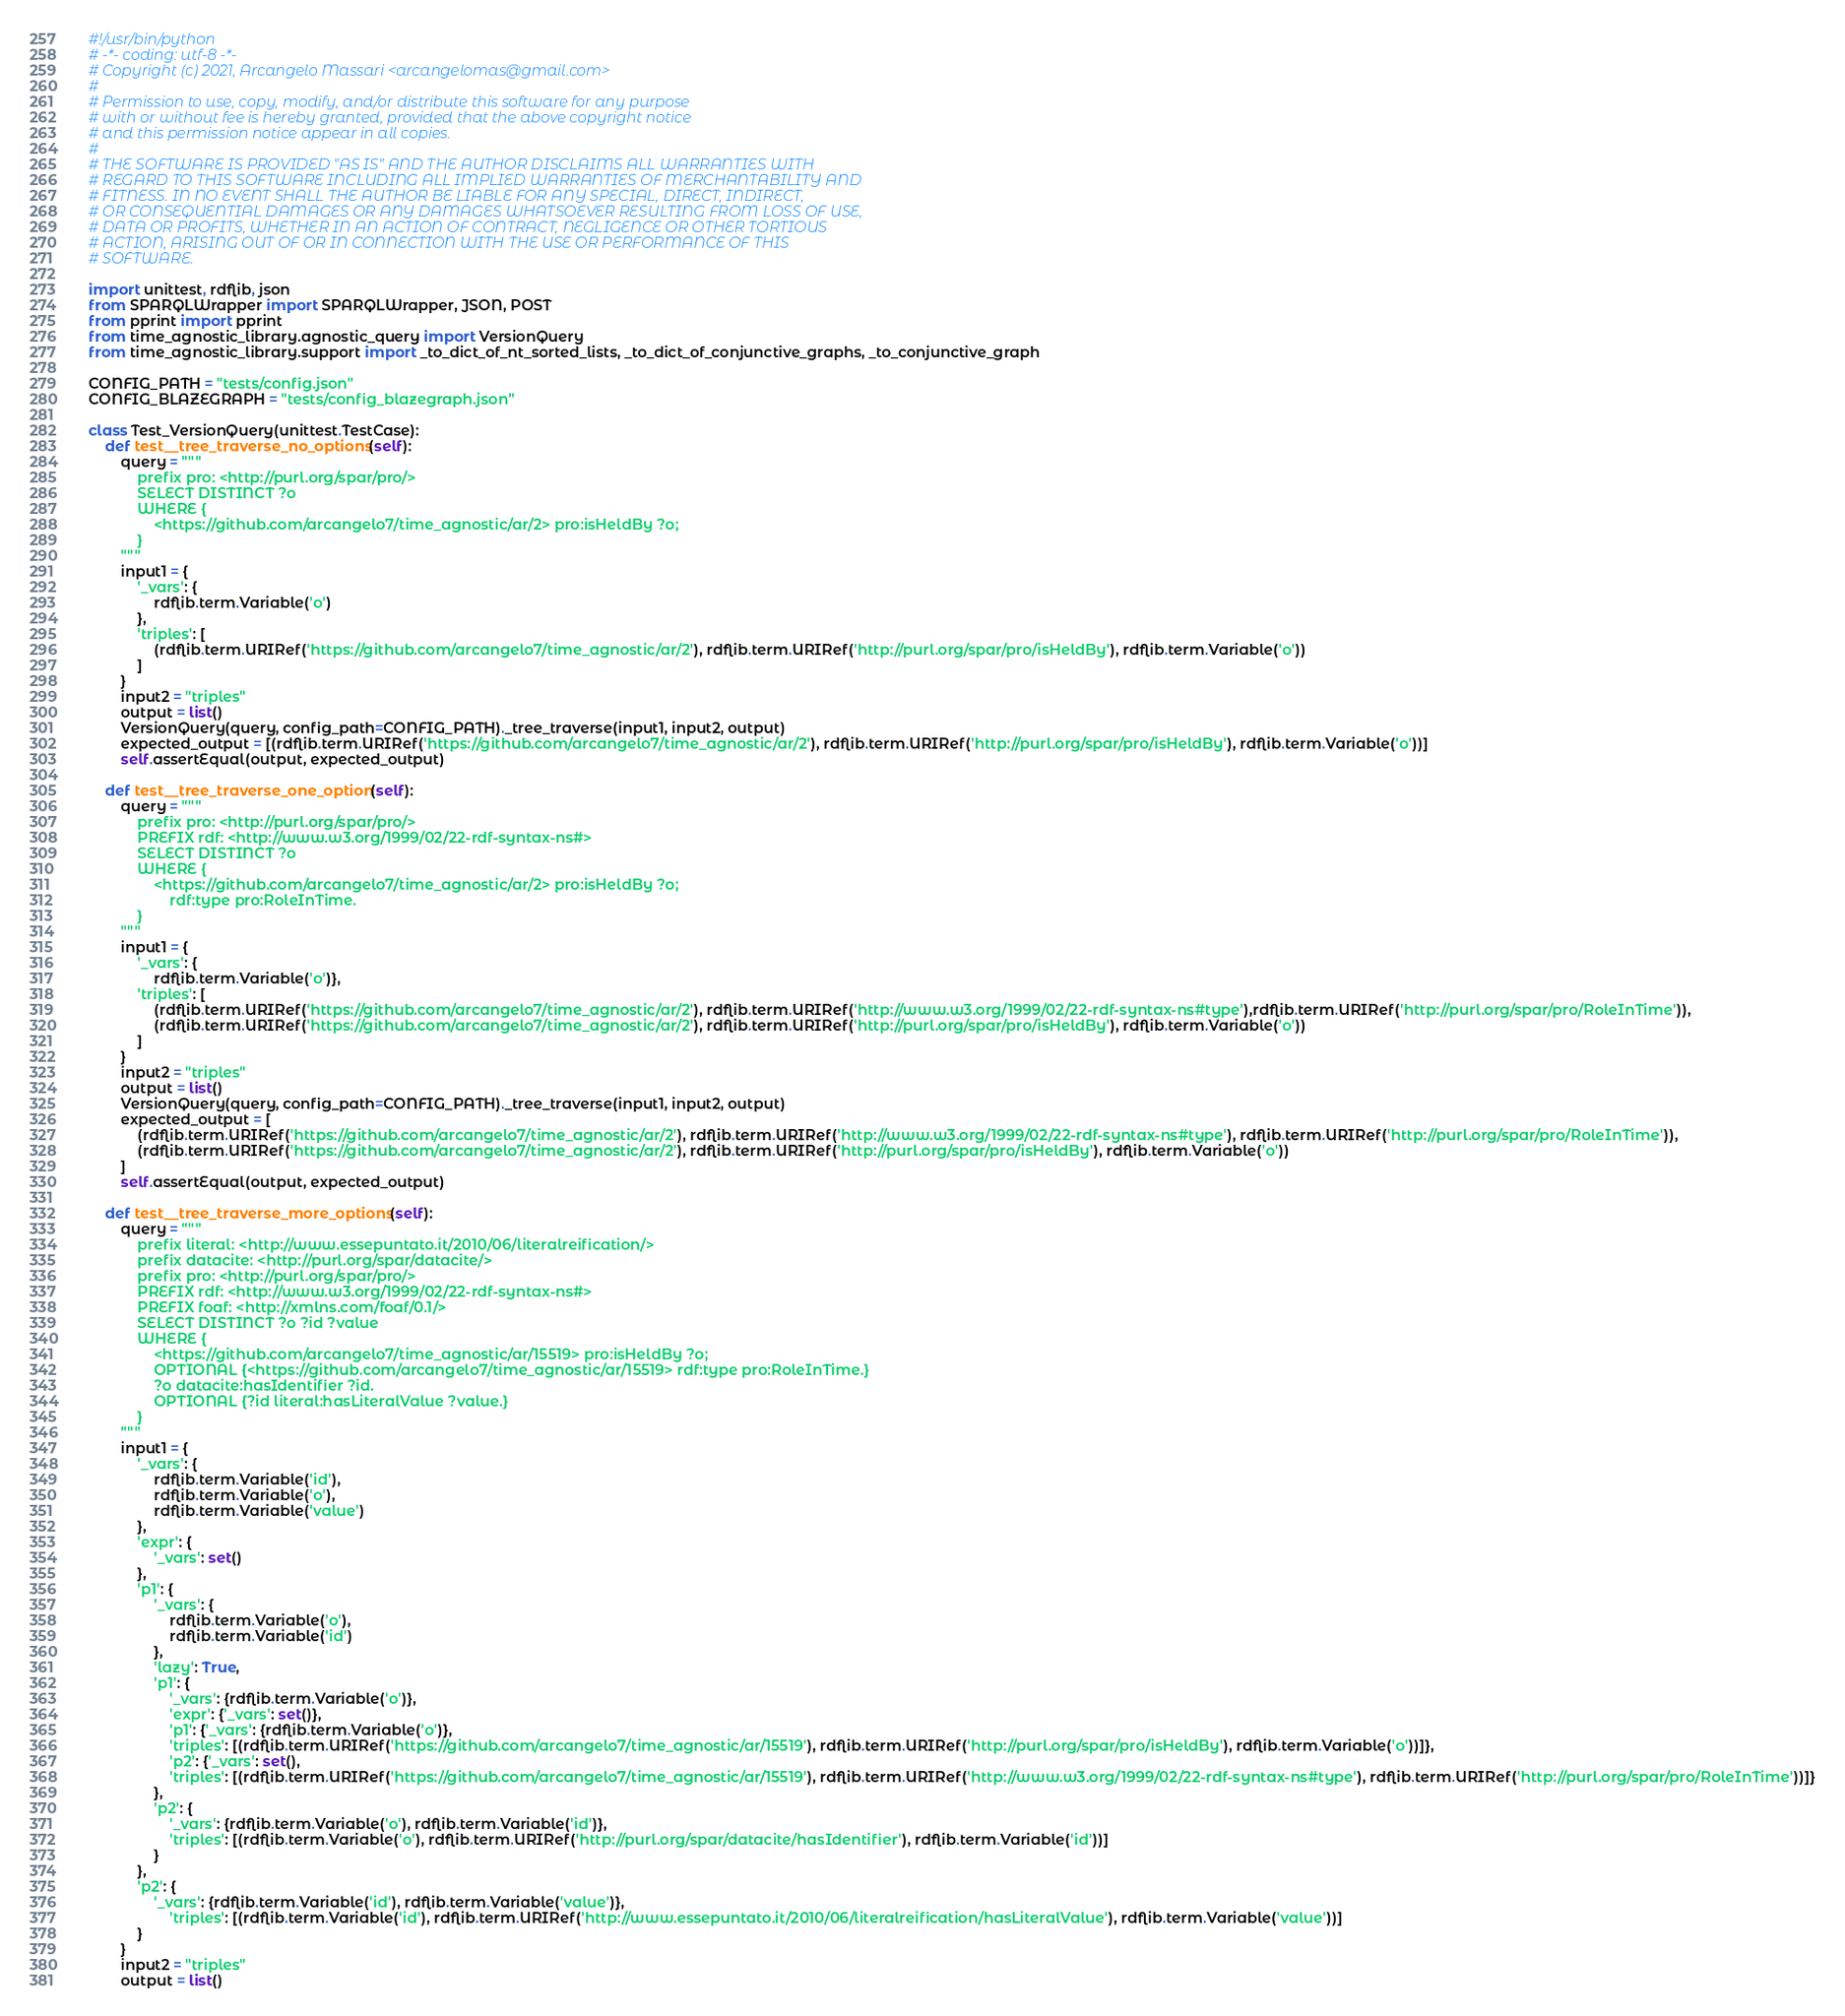Convert code to text. <code><loc_0><loc_0><loc_500><loc_500><_Python_>#!/usr/bin/python
# -*- coding: utf-8 -*-
# Copyright (c) 2021, Arcangelo Massari <arcangelomas@gmail.com>
#
# Permission to use, copy, modify, and/or distribute this software for any purpose
# with or without fee is hereby granted, provided that the above copyright notice
# and this permission notice appear in all copies.
#
# THE SOFTWARE IS PROVIDED "AS IS" AND THE AUTHOR DISCLAIMS ALL WARRANTIES WITH
# REGARD TO THIS SOFTWARE INCLUDING ALL IMPLIED WARRANTIES OF MERCHANTABILITY AND
# FITNESS. IN NO EVENT SHALL THE AUTHOR BE LIABLE FOR ANY SPECIAL, DIRECT, INDIRECT,
# OR CONSEQUENTIAL DAMAGES OR ANY DAMAGES WHATSOEVER RESULTING FROM LOSS OF USE,
# DATA OR PROFITS, WHETHER IN AN ACTION OF CONTRACT, NEGLIGENCE OR OTHER TORTIOUS
# ACTION, ARISING OUT OF OR IN CONNECTION WITH THE USE OR PERFORMANCE OF THIS
# SOFTWARE.

import unittest, rdflib, json
from SPARQLWrapper import SPARQLWrapper, JSON, POST
from pprint import pprint
from time_agnostic_library.agnostic_query import VersionQuery
from time_agnostic_library.support import _to_dict_of_nt_sorted_lists, _to_dict_of_conjunctive_graphs, _to_conjunctive_graph

CONFIG_PATH = "tests/config.json"
CONFIG_BLAZEGRAPH = "tests/config_blazegraph.json"

class Test_VersionQuery(unittest.TestCase):        
    def test__tree_traverse_no_options(self):
        query = """
            prefix pro: <http://purl.org/spar/pro/>
            SELECT DISTINCT ?o
            WHERE {
                <https://github.com/arcangelo7/time_agnostic/ar/2> pro:isHeldBy ?o;
            }
        """
        input1 = {
            '_vars': {
                rdflib.term.Variable('o')
            },
            'triples': [
                (rdflib.term.URIRef('https://github.com/arcangelo7/time_agnostic/ar/2'), rdflib.term.URIRef('http://purl.org/spar/pro/isHeldBy'), rdflib.term.Variable('o'))
            ]
        }
        input2 = "triples"
        output = list()
        VersionQuery(query, config_path=CONFIG_PATH)._tree_traverse(input1, input2, output)
        expected_output = [(rdflib.term.URIRef('https://github.com/arcangelo7/time_agnostic/ar/2'), rdflib.term.URIRef('http://purl.org/spar/pro/isHeldBy'), rdflib.term.Variable('o'))]
        self.assertEqual(output, expected_output)

    def test__tree_traverse_one_option(self):
        query = """
            prefix pro: <http://purl.org/spar/pro/>
            PREFIX rdf: <http://www.w3.org/1999/02/22-rdf-syntax-ns#>
            SELECT DISTINCT ?o
            WHERE {
                <https://github.com/arcangelo7/time_agnostic/ar/2> pro:isHeldBy ?o;
                    rdf:type pro:RoleInTime.
            }
        """
        input1 = {
            '_vars': {
                rdflib.term.Variable('o')},
            'triples': [
                (rdflib.term.URIRef('https://github.com/arcangelo7/time_agnostic/ar/2'), rdflib.term.URIRef('http://www.w3.org/1999/02/22-rdf-syntax-ns#type'),rdflib.term.URIRef('http://purl.org/spar/pro/RoleInTime')),
                (rdflib.term.URIRef('https://github.com/arcangelo7/time_agnostic/ar/2'), rdflib.term.URIRef('http://purl.org/spar/pro/isHeldBy'), rdflib.term.Variable('o'))
            ]
        }
        input2 = "triples"
        output = list()
        VersionQuery(query, config_path=CONFIG_PATH)._tree_traverse(input1, input2, output)
        expected_output = [
            (rdflib.term.URIRef('https://github.com/arcangelo7/time_agnostic/ar/2'), rdflib.term.URIRef('http://www.w3.org/1999/02/22-rdf-syntax-ns#type'), rdflib.term.URIRef('http://purl.org/spar/pro/RoleInTime')), 
            (rdflib.term.URIRef('https://github.com/arcangelo7/time_agnostic/ar/2'), rdflib.term.URIRef('http://purl.org/spar/pro/isHeldBy'), rdflib.term.Variable('o'))
        ]
        self.assertEqual(output, expected_output)

    def test__tree_traverse_more_options(self):
        query = """
            prefix literal: <http://www.essepuntato.it/2010/06/literalreification/>
            prefix datacite: <http://purl.org/spar/datacite/>
            prefix pro: <http://purl.org/spar/pro/>
            PREFIX rdf: <http://www.w3.org/1999/02/22-rdf-syntax-ns#>
            PREFIX foaf: <http://xmlns.com/foaf/0.1/>
            SELECT DISTINCT ?o ?id ?value
            WHERE {
                <https://github.com/arcangelo7/time_agnostic/ar/15519> pro:isHeldBy ?o;
                OPTIONAL {<https://github.com/arcangelo7/time_agnostic/ar/15519> rdf:type pro:RoleInTime.}
                ?o datacite:hasIdentifier ?id.
                OPTIONAL {?id literal:hasLiteralValue ?value.}
            }
        """
        input1 = {
            '_vars': {
                rdflib.term.Variable('id'),
                rdflib.term.Variable('o'),
                rdflib.term.Variable('value')
            },
            'expr': {
                '_vars': set()
            },
            'p1': {
                '_vars': {
                    rdflib.term.Variable('o'), 
                    rdflib.term.Variable('id')
                },
                'lazy': True,
                'p1': {
                    '_vars': {rdflib.term.Variable('o')},
                    'expr': {'_vars': set()},
                    'p1': {'_vars': {rdflib.term.Variable('o')},
                    'triples': [(rdflib.term.URIRef('https://github.com/arcangelo7/time_agnostic/ar/15519'), rdflib.term.URIRef('http://purl.org/spar/pro/isHeldBy'), rdflib.term.Variable('o'))]},
                    'p2': {'_vars': set(),
                    'triples': [(rdflib.term.URIRef('https://github.com/arcangelo7/time_agnostic/ar/15519'), rdflib.term.URIRef('http://www.w3.org/1999/02/22-rdf-syntax-ns#type'), rdflib.term.URIRef('http://purl.org/spar/pro/RoleInTime'))]}
                },
                'p2': {
                    '_vars': {rdflib.term.Variable('o'), rdflib.term.Variable('id')},
                    'triples': [(rdflib.term.Variable('o'), rdflib.term.URIRef('http://purl.org/spar/datacite/hasIdentifier'), rdflib.term.Variable('id'))]
                }
            },
            'p2': {
                '_vars': {rdflib.term.Variable('id'), rdflib.term.Variable('value')},
                    'triples': [(rdflib.term.Variable('id'), rdflib.term.URIRef('http://www.essepuntato.it/2010/06/literalreification/hasLiteralValue'), rdflib.term.Variable('value'))]
            }
        }
        input2 = "triples"
        output = list()</code> 